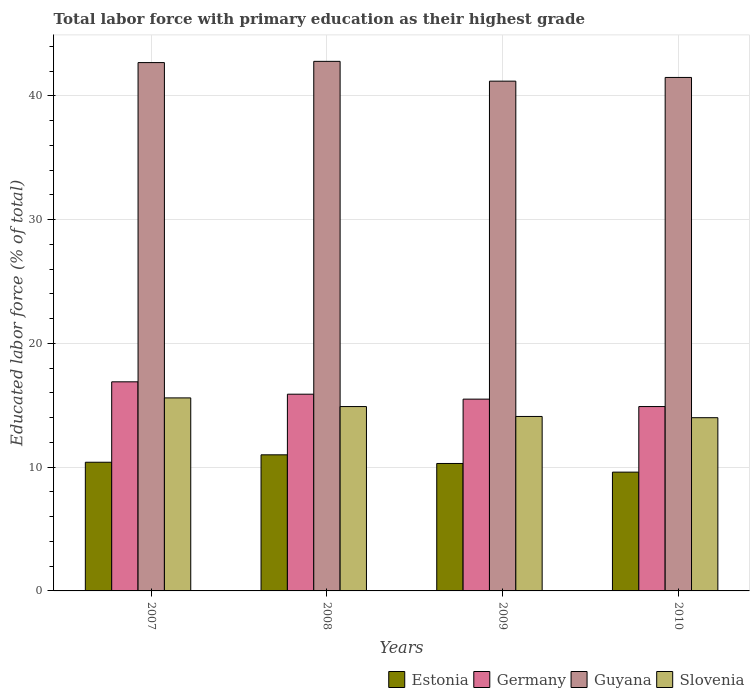How many groups of bars are there?
Provide a succinct answer. 4. Are the number of bars per tick equal to the number of legend labels?
Ensure brevity in your answer.  Yes. How many bars are there on the 2nd tick from the right?
Provide a short and direct response. 4. What is the percentage of total labor force with primary education in Germany in 2010?
Make the answer very short. 14.9. Across all years, what is the maximum percentage of total labor force with primary education in Slovenia?
Provide a short and direct response. 15.6. What is the total percentage of total labor force with primary education in Guyana in the graph?
Ensure brevity in your answer.  168.2. What is the difference between the percentage of total labor force with primary education in Guyana in 2009 and that in 2010?
Make the answer very short. -0.3. What is the difference between the percentage of total labor force with primary education in Slovenia in 2007 and the percentage of total labor force with primary education in Guyana in 2010?
Make the answer very short. -25.9. What is the average percentage of total labor force with primary education in Germany per year?
Offer a very short reply. 15.8. In the year 2009, what is the difference between the percentage of total labor force with primary education in Germany and percentage of total labor force with primary education in Slovenia?
Keep it short and to the point. 1.4. In how many years, is the percentage of total labor force with primary education in Germany greater than 24 %?
Your answer should be very brief. 0. What is the ratio of the percentage of total labor force with primary education in Slovenia in 2007 to that in 2009?
Make the answer very short. 1.11. Is the percentage of total labor force with primary education in Slovenia in 2007 less than that in 2008?
Offer a very short reply. No. Is the difference between the percentage of total labor force with primary education in Germany in 2008 and 2009 greater than the difference between the percentage of total labor force with primary education in Slovenia in 2008 and 2009?
Offer a terse response. No. What is the difference between the highest and the second highest percentage of total labor force with primary education in Germany?
Give a very brief answer. 1. What is the difference between the highest and the lowest percentage of total labor force with primary education in Guyana?
Make the answer very short. 1.6. Is it the case that in every year, the sum of the percentage of total labor force with primary education in Slovenia and percentage of total labor force with primary education in Germany is greater than the sum of percentage of total labor force with primary education in Estonia and percentage of total labor force with primary education in Guyana?
Make the answer very short. No. What does the 2nd bar from the left in 2008 represents?
Make the answer very short. Germany. What does the 4th bar from the right in 2010 represents?
Provide a short and direct response. Estonia. How many bars are there?
Provide a short and direct response. 16. Are the values on the major ticks of Y-axis written in scientific E-notation?
Provide a short and direct response. No. Does the graph contain grids?
Give a very brief answer. Yes. What is the title of the graph?
Offer a terse response. Total labor force with primary education as their highest grade. What is the label or title of the Y-axis?
Provide a succinct answer. Educated labor force (% of total). What is the Educated labor force (% of total) of Estonia in 2007?
Provide a short and direct response. 10.4. What is the Educated labor force (% of total) of Germany in 2007?
Offer a terse response. 16.9. What is the Educated labor force (% of total) in Guyana in 2007?
Make the answer very short. 42.7. What is the Educated labor force (% of total) in Slovenia in 2007?
Your answer should be very brief. 15.6. What is the Educated labor force (% of total) of Estonia in 2008?
Ensure brevity in your answer.  11. What is the Educated labor force (% of total) of Germany in 2008?
Provide a succinct answer. 15.9. What is the Educated labor force (% of total) in Guyana in 2008?
Ensure brevity in your answer.  42.8. What is the Educated labor force (% of total) in Slovenia in 2008?
Your response must be concise. 14.9. What is the Educated labor force (% of total) in Estonia in 2009?
Provide a succinct answer. 10.3. What is the Educated labor force (% of total) in Germany in 2009?
Provide a short and direct response. 15.5. What is the Educated labor force (% of total) of Guyana in 2009?
Provide a succinct answer. 41.2. What is the Educated labor force (% of total) in Slovenia in 2009?
Your response must be concise. 14.1. What is the Educated labor force (% of total) of Estonia in 2010?
Ensure brevity in your answer.  9.6. What is the Educated labor force (% of total) in Germany in 2010?
Provide a short and direct response. 14.9. What is the Educated labor force (% of total) in Guyana in 2010?
Offer a terse response. 41.5. Across all years, what is the maximum Educated labor force (% of total) of Germany?
Your answer should be very brief. 16.9. Across all years, what is the maximum Educated labor force (% of total) of Guyana?
Provide a succinct answer. 42.8. Across all years, what is the maximum Educated labor force (% of total) in Slovenia?
Your response must be concise. 15.6. Across all years, what is the minimum Educated labor force (% of total) in Estonia?
Make the answer very short. 9.6. Across all years, what is the minimum Educated labor force (% of total) of Germany?
Offer a terse response. 14.9. Across all years, what is the minimum Educated labor force (% of total) of Guyana?
Keep it short and to the point. 41.2. What is the total Educated labor force (% of total) of Estonia in the graph?
Your answer should be compact. 41.3. What is the total Educated labor force (% of total) in Germany in the graph?
Your answer should be compact. 63.2. What is the total Educated labor force (% of total) in Guyana in the graph?
Keep it short and to the point. 168.2. What is the total Educated labor force (% of total) of Slovenia in the graph?
Give a very brief answer. 58.6. What is the difference between the Educated labor force (% of total) in Estonia in 2007 and that in 2008?
Provide a succinct answer. -0.6. What is the difference between the Educated labor force (% of total) of Slovenia in 2007 and that in 2008?
Offer a very short reply. 0.7. What is the difference between the Educated labor force (% of total) of Germany in 2007 and that in 2009?
Make the answer very short. 1.4. What is the difference between the Educated labor force (% of total) of Slovenia in 2007 and that in 2009?
Provide a succinct answer. 1.5. What is the difference between the Educated labor force (% of total) of Estonia in 2007 and that in 2010?
Make the answer very short. 0.8. What is the difference between the Educated labor force (% of total) of Germany in 2007 and that in 2010?
Give a very brief answer. 2. What is the difference between the Educated labor force (% of total) of Slovenia in 2007 and that in 2010?
Keep it short and to the point. 1.6. What is the difference between the Educated labor force (% of total) in Germany in 2008 and that in 2009?
Give a very brief answer. 0.4. What is the difference between the Educated labor force (% of total) of Guyana in 2008 and that in 2009?
Offer a very short reply. 1.6. What is the difference between the Educated labor force (% of total) in Slovenia in 2008 and that in 2009?
Your answer should be very brief. 0.8. What is the difference between the Educated labor force (% of total) of Estonia in 2009 and that in 2010?
Keep it short and to the point. 0.7. What is the difference between the Educated labor force (% of total) of Germany in 2009 and that in 2010?
Ensure brevity in your answer.  0.6. What is the difference between the Educated labor force (% of total) in Guyana in 2009 and that in 2010?
Give a very brief answer. -0.3. What is the difference between the Educated labor force (% of total) in Estonia in 2007 and the Educated labor force (% of total) in Guyana in 2008?
Give a very brief answer. -32.4. What is the difference between the Educated labor force (% of total) in Germany in 2007 and the Educated labor force (% of total) in Guyana in 2008?
Your answer should be very brief. -25.9. What is the difference between the Educated labor force (% of total) of Guyana in 2007 and the Educated labor force (% of total) of Slovenia in 2008?
Your answer should be very brief. 27.8. What is the difference between the Educated labor force (% of total) in Estonia in 2007 and the Educated labor force (% of total) in Germany in 2009?
Provide a succinct answer. -5.1. What is the difference between the Educated labor force (% of total) in Estonia in 2007 and the Educated labor force (% of total) in Guyana in 2009?
Provide a succinct answer. -30.8. What is the difference between the Educated labor force (% of total) of Germany in 2007 and the Educated labor force (% of total) of Guyana in 2009?
Keep it short and to the point. -24.3. What is the difference between the Educated labor force (% of total) in Guyana in 2007 and the Educated labor force (% of total) in Slovenia in 2009?
Provide a succinct answer. 28.6. What is the difference between the Educated labor force (% of total) in Estonia in 2007 and the Educated labor force (% of total) in Germany in 2010?
Give a very brief answer. -4.5. What is the difference between the Educated labor force (% of total) in Estonia in 2007 and the Educated labor force (% of total) in Guyana in 2010?
Your response must be concise. -31.1. What is the difference between the Educated labor force (% of total) in Germany in 2007 and the Educated labor force (% of total) in Guyana in 2010?
Provide a succinct answer. -24.6. What is the difference between the Educated labor force (% of total) in Guyana in 2007 and the Educated labor force (% of total) in Slovenia in 2010?
Your response must be concise. 28.7. What is the difference between the Educated labor force (% of total) in Estonia in 2008 and the Educated labor force (% of total) in Guyana in 2009?
Give a very brief answer. -30.2. What is the difference between the Educated labor force (% of total) of Germany in 2008 and the Educated labor force (% of total) of Guyana in 2009?
Your answer should be very brief. -25.3. What is the difference between the Educated labor force (% of total) of Germany in 2008 and the Educated labor force (% of total) of Slovenia in 2009?
Keep it short and to the point. 1.8. What is the difference between the Educated labor force (% of total) in Guyana in 2008 and the Educated labor force (% of total) in Slovenia in 2009?
Offer a very short reply. 28.7. What is the difference between the Educated labor force (% of total) in Estonia in 2008 and the Educated labor force (% of total) in Germany in 2010?
Make the answer very short. -3.9. What is the difference between the Educated labor force (% of total) in Estonia in 2008 and the Educated labor force (% of total) in Guyana in 2010?
Make the answer very short. -30.5. What is the difference between the Educated labor force (% of total) of Germany in 2008 and the Educated labor force (% of total) of Guyana in 2010?
Provide a short and direct response. -25.6. What is the difference between the Educated labor force (% of total) in Germany in 2008 and the Educated labor force (% of total) in Slovenia in 2010?
Provide a short and direct response. 1.9. What is the difference between the Educated labor force (% of total) of Guyana in 2008 and the Educated labor force (% of total) of Slovenia in 2010?
Keep it short and to the point. 28.8. What is the difference between the Educated labor force (% of total) of Estonia in 2009 and the Educated labor force (% of total) of Germany in 2010?
Ensure brevity in your answer.  -4.6. What is the difference between the Educated labor force (% of total) of Estonia in 2009 and the Educated labor force (% of total) of Guyana in 2010?
Provide a short and direct response. -31.2. What is the difference between the Educated labor force (% of total) of Guyana in 2009 and the Educated labor force (% of total) of Slovenia in 2010?
Your answer should be very brief. 27.2. What is the average Educated labor force (% of total) of Estonia per year?
Provide a succinct answer. 10.32. What is the average Educated labor force (% of total) of Guyana per year?
Offer a very short reply. 42.05. What is the average Educated labor force (% of total) of Slovenia per year?
Make the answer very short. 14.65. In the year 2007, what is the difference between the Educated labor force (% of total) of Estonia and Educated labor force (% of total) of Guyana?
Make the answer very short. -32.3. In the year 2007, what is the difference between the Educated labor force (% of total) in Estonia and Educated labor force (% of total) in Slovenia?
Your answer should be very brief. -5.2. In the year 2007, what is the difference between the Educated labor force (% of total) of Germany and Educated labor force (% of total) of Guyana?
Provide a short and direct response. -25.8. In the year 2007, what is the difference between the Educated labor force (% of total) of Guyana and Educated labor force (% of total) of Slovenia?
Offer a very short reply. 27.1. In the year 2008, what is the difference between the Educated labor force (% of total) of Estonia and Educated labor force (% of total) of Germany?
Your answer should be compact. -4.9. In the year 2008, what is the difference between the Educated labor force (% of total) of Estonia and Educated labor force (% of total) of Guyana?
Provide a succinct answer. -31.8. In the year 2008, what is the difference between the Educated labor force (% of total) of Estonia and Educated labor force (% of total) of Slovenia?
Give a very brief answer. -3.9. In the year 2008, what is the difference between the Educated labor force (% of total) in Germany and Educated labor force (% of total) in Guyana?
Your answer should be compact. -26.9. In the year 2008, what is the difference between the Educated labor force (% of total) of Guyana and Educated labor force (% of total) of Slovenia?
Provide a short and direct response. 27.9. In the year 2009, what is the difference between the Educated labor force (% of total) of Estonia and Educated labor force (% of total) of Germany?
Ensure brevity in your answer.  -5.2. In the year 2009, what is the difference between the Educated labor force (% of total) of Estonia and Educated labor force (% of total) of Guyana?
Make the answer very short. -30.9. In the year 2009, what is the difference between the Educated labor force (% of total) of Germany and Educated labor force (% of total) of Guyana?
Keep it short and to the point. -25.7. In the year 2009, what is the difference between the Educated labor force (% of total) of Germany and Educated labor force (% of total) of Slovenia?
Offer a terse response. 1.4. In the year 2009, what is the difference between the Educated labor force (% of total) in Guyana and Educated labor force (% of total) in Slovenia?
Give a very brief answer. 27.1. In the year 2010, what is the difference between the Educated labor force (% of total) in Estonia and Educated labor force (% of total) in Guyana?
Your response must be concise. -31.9. In the year 2010, what is the difference between the Educated labor force (% of total) in Estonia and Educated labor force (% of total) in Slovenia?
Give a very brief answer. -4.4. In the year 2010, what is the difference between the Educated labor force (% of total) of Germany and Educated labor force (% of total) of Guyana?
Provide a short and direct response. -26.6. What is the ratio of the Educated labor force (% of total) of Estonia in 2007 to that in 2008?
Make the answer very short. 0.95. What is the ratio of the Educated labor force (% of total) of Germany in 2007 to that in 2008?
Your answer should be very brief. 1.06. What is the ratio of the Educated labor force (% of total) in Slovenia in 2007 to that in 2008?
Ensure brevity in your answer.  1.05. What is the ratio of the Educated labor force (% of total) in Estonia in 2007 to that in 2009?
Your answer should be compact. 1.01. What is the ratio of the Educated labor force (% of total) in Germany in 2007 to that in 2009?
Your answer should be very brief. 1.09. What is the ratio of the Educated labor force (% of total) of Guyana in 2007 to that in 2009?
Your answer should be compact. 1.04. What is the ratio of the Educated labor force (% of total) in Slovenia in 2007 to that in 2009?
Give a very brief answer. 1.11. What is the ratio of the Educated labor force (% of total) in Estonia in 2007 to that in 2010?
Your answer should be compact. 1.08. What is the ratio of the Educated labor force (% of total) in Germany in 2007 to that in 2010?
Provide a succinct answer. 1.13. What is the ratio of the Educated labor force (% of total) in Guyana in 2007 to that in 2010?
Give a very brief answer. 1.03. What is the ratio of the Educated labor force (% of total) in Slovenia in 2007 to that in 2010?
Your answer should be compact. 1.11. What is the ratio of the Educated labor force (% of total) in Estonia in 2008 to that in 2009?
Your answer should be compact. 1.07. What is the ratio of the Educated labor force (% of total) in Germany in 2008 to that in 2009?
Offer a terse response. 1.03. What is the ratio of the Educated labor force (% of total) of Guyana in 2008 to that in 2009?
Make the answer very short. 1.04. What is the ratio of the Educated labor force (% of total) in Slovenia in 2008 to that in 2009?
Offer a terse response. 1.06. What is the ratio of the Educated labor force (% of total) of Estonia in 2008 to that in 2010?
Make the answer very short. 1.15. What is the ratio of the Educated labor force (% of total) in Germany in 2008 to that in 2010?
Keep it short and to the point. 1.07. What is the ratio of the Educated labor force (% of total) of Guyana in 2008 to that in 2010?
Offer a terse response. 1.03. What is the ratio of the Educated labor force (% of total) of Slovenia in 2008 to that in 2010?
Provide a succinct answer. 1.06. What is the ratio of the Educated labor force (% of total) of Estonia in 2009 to that in 2010?
Keep it short and to the point. 1.07. What is the ratio of the Educated labor force (% of total) of Germany in 2009 to that in 2010?
Provide a short and direct response. 1.04. What is the ratio of the Educated labor force (% of total) in Slovenia in 2009 to that in 2010?
Offer a very short reply. 1.01. What is the difference between the highest and the second highest Educated labor force (% of total) in Estonia?
Provide a succinct answer. 0.6. What is the difference between the highest and the lowest Educated labor force (% of total) in Guyana?
Offer a very short reply. 1.6. What is the difference between the highest and the lowest Educated labor force (% of total) of Slovenia?
Provide a succinct answer. 1.6. 